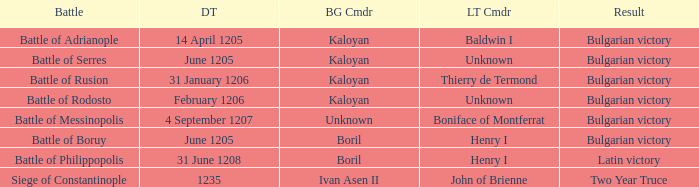What is the Bulgarian Commander of the Battle of Rusion? Kaloyan. 